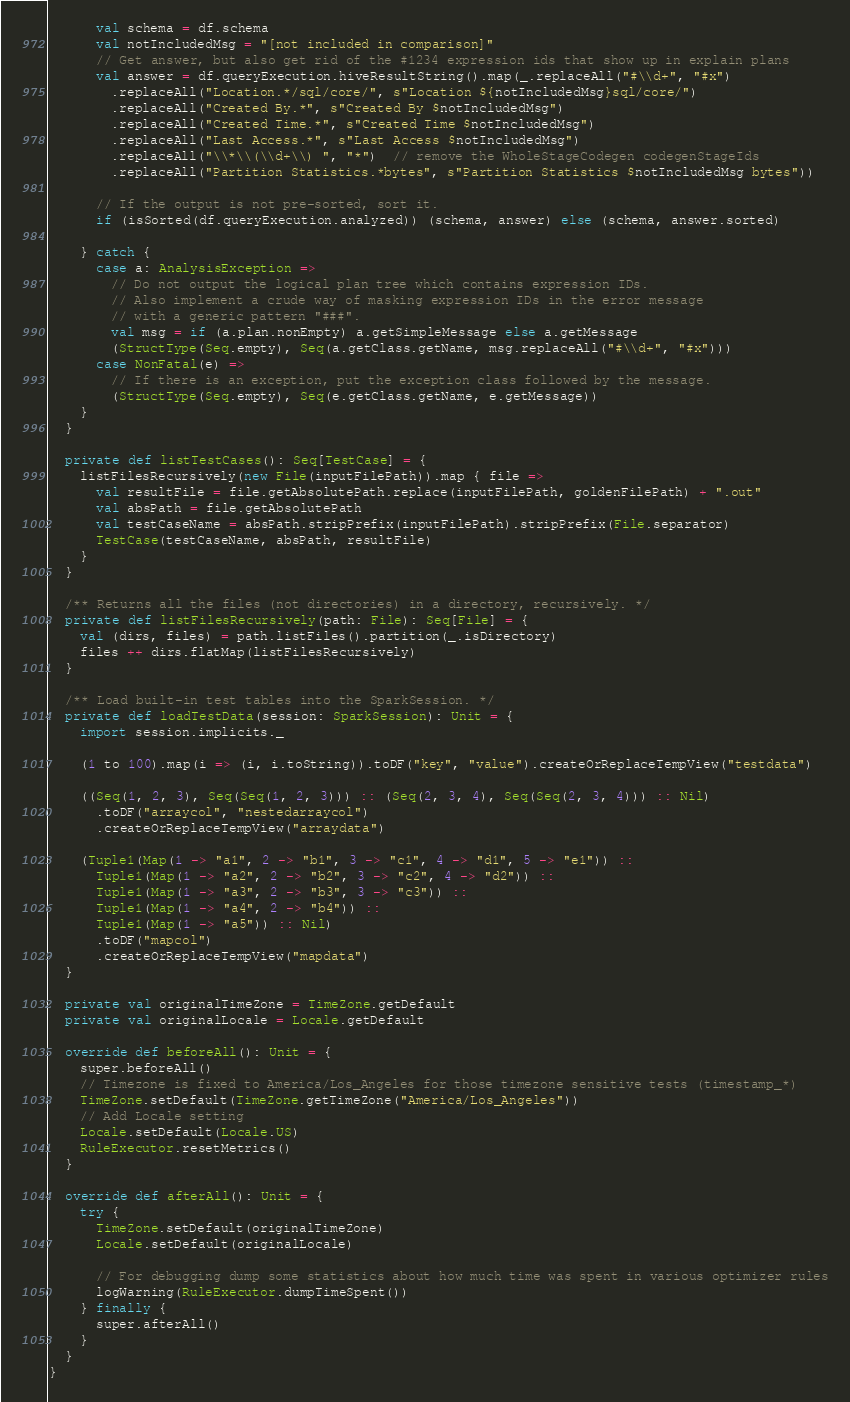Convert code to text. <code><loc_0><loc_0><loc_500><loc_500><_Scala_>      val schema = df.schema
      val notIncludedMsg = "[not included in comparison]"
      // Get answer, but also get rid of the #1234 expression ids that show up in explain plans
      val answer = df.queryExecution.hiveResultString().map(_.replaceAll("#\\d+", "#x")
        .replaceAll("Location.*/sql/core/", s"Location ${notIncludedMsg}sql/core/")
        .replaceAll("Created By.*", s"Created By $notIncludedMsg")
        .replaceAll("Created Time.*", s"Created Time $notIncludedMsg")
        .replaceAll("Last Access.*", s"Last Access $notIncludedMsg")
        .replaceAll("\\*\\(\\d+\\) ", "*")  // remove the WholeStageCodegen codegenStageIds
        .replaceAll("Partition Statistics.*bytes", s"Partition Statistics $notIncludedMsg bytes"))

      // If the output is not pre-sorted, sort it.
      if (isSorted(df.queryExecution.analyzed)) (schema, answer) else (schema, answer.sorted)

    } catch {
      case a: AnalysisException =>
        // Do not output the logical plan tree which contains expression IDs.
        // Also implement a crude way of masking expression IDs in the error message
        // with a generic pattern "###".
        val msg = if (a.plan.nonEmpty) a.getSimpleMessage else a.getMessage
        (StructType(Seq.empty), Seq(a.getClass.getName, msg.replaceAll("#\\d+", "#x")))
      case NonFatal(e) =>
        // If there is an exception, put the exception class followed by the message.
        (StructType(Seq.empty), Seq(e.getClass.getName, e.getMessage))
    }
  }

  private def listTestCases(): Seq[TestCase] = {
    listFilesRecursively(new File(inputFilePath)).map { file =>
      val resultFile = file.getAbsolutePath.replace(inputFilePath, goldenFilePath) + ".out"
      val absPath = file.getAbsolutePath
      val testCaseName = absPath.stripPrefix(inputFilePath).stripPrefix(File.separator)
      TestCase(testCaseName, absPath, resultFile)
    }
  }

  /** Returns all the files (not directories) in a directory, recursively. */
  private def listFilesRecursively(path: File): Seq[File] = {
    val (dirs, files) = path.listFiles().partition(_.isDirectory)
    files ++ dirs.flatMap(listFilesRecursively)
  }

  /** Load built-in test tables into the SparkSession. */
  private def loadTestData(session: SparkSession): Unit = {
    import session.implicits._

    (1 to 100).map(i => (i, i.toString)).toDF("key", "value").createOrReplaceTempView("testdata")

    ((Seq(1, 2, 3), Seq(Seq(1, 2, 3))) :: (Seq(2, 3, 4), Seq(Seq(2, 3, 4))) :: Nil)
      .toDF("arraycol", "nestedarraycol")
      .createOrReplaceTempView("arraydata")

    (Tuple1(Map(1 -> "a1", 2 -> "b1", 3 -> "c1", 4 -> "d1", 5 -> "e1")) ::
      Tuple1(Map(1 -> "a2", 2 -> "b2", 3 -> "c2", 4 -> "d2")) ::
      Tuple1(Map(1 -> "a3", 2 -> "b3", 3 -> "c3")) ::
      Tuple1(Map(1 -> "a4", 2 -> "b4")) ::
      Tuple1(Map(1 -> "a5")) :: Nil)
      .toDF("mapcol")
      .createOrReplaceTempView("mapdata")
  }

  private val originalTimeZone = TimeZone.getDefault
  private val originalLocale = Locale.getDefault

  override def beforeAll(): Unit = {
    super.beforeAll()
    // Timezone is fixed to America/Los_Angeles for those timezone sensitive tests (timestamp_*)
    TimeZone.setDefault(TimeZone.getTimeZone("America/Los_Angeles"))
    // Add Locale setting
    Locale.setDefault(Locale.US)
    RuleExecutor.resetMetrics()
  }

  override def afterAll(): Unit = {
    try {
      TimeZone.setDefault(originalTimeZone)
      Locale.setDefault(originalLocale)

      // For debugging dump some statistics about how much time was spent in various optimizer rules
      logWarning(RuleExecutor.dumpTimeSpent())
    } finally {
      super.afterAll()
    }
  }
}
</code> 